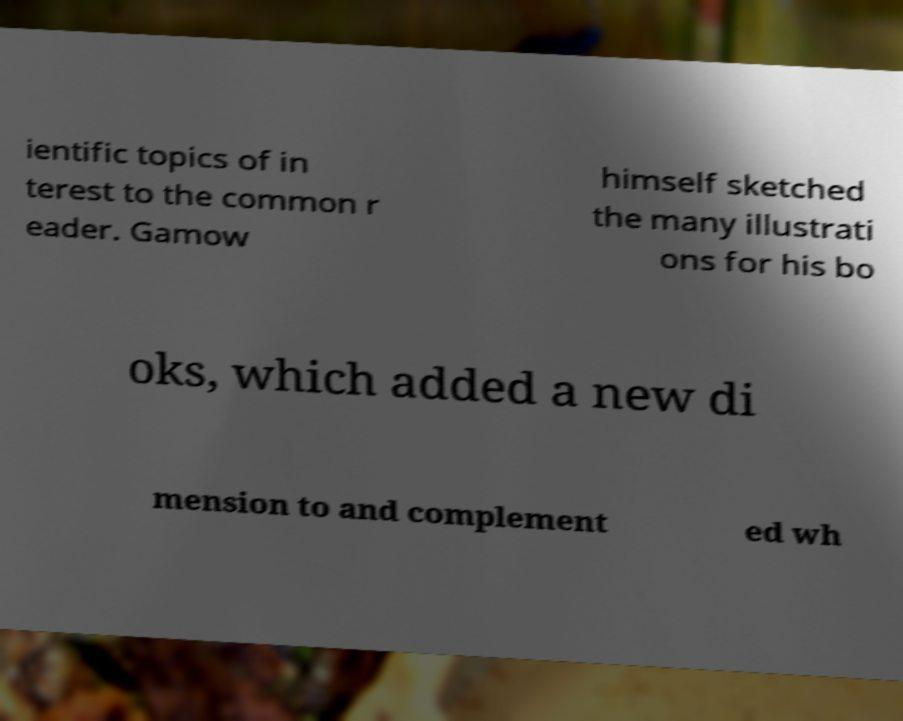There's text embedded in this image that I need extracted. Can you transcribe it verbatim? ientific topics of in terest to the common r eader. Gamow himself sketched the many illustrati ons for his bo oks, which added a new di mension to and complement ed wh 